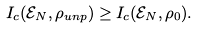Convert formula to latex. <formula><loc_0><loc_0><loc_500><loc_500>I _ { c } ( \mathcal { E } _ { N } , \rho _ { u n p } ) \geq I _ { c } ( \mathcal { E } _ { N } , \rho _ { 0 } ) .</formula> 